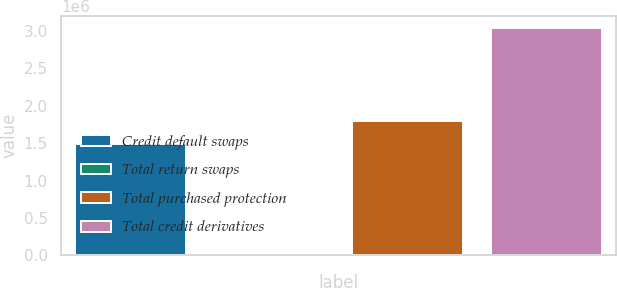Convert chart to OTSL. <chart><loc_0><loc_0><loc_500><loc_500><bar_chart><fcel>Credit default swaps<fcel>Total return swaps<fcel>Total purchased protection<fcel>Total credit derivatives<nl><fcel>1.49064e+06<fcel>13551<fcel>1.79392e+06<fcel>3.04638e+06<nl></chart> 